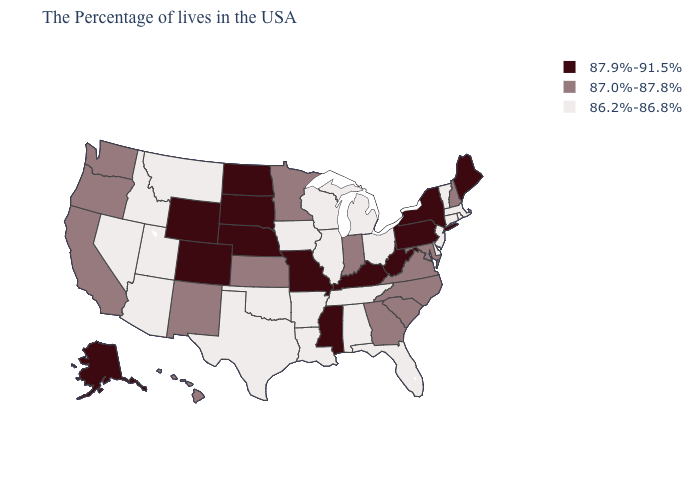What is the value of Indiana?
Write a very short answer. 87.0%-87.8%. How many symbols are there in the legend?
Answer briefly. 3. Name the states that have a value in the range 87.9%-91.5%?
Be succinct. Maine, New York, Pennsylvania, West Virginia, Kentucky, Mississippi, Missouri, Nebraska, South Dakota, North Dakota, Wyoming, Colorado, Alaska. Name the states that have a value in the range 86.2%-86.8%?
Concise answer only. Massachusetts, Rhode Island, Vermont, Connecticut, New Jersey, Delaware, Ohio, Florida, Michigan, Alabama, Tennessee, Wisconsin, Illinois, Louisiana, Arkansas, Iowa, Oklahoma, Texas, Utah, Montana, Arizona, Idaho, Nevada. Name the states that have a value in the range 86.2%-86.8%?
Quick response, please. Massachusetts, Rhode Island, Vermont, Connecticut, New Jersey, Delaware, Ohio, Florida, Michigan, Alabama, Tennessee, Wisconsin, Illinois, Louisiana, Arkansas, Iowa, Oklahoma, Texas, Utah, Montana, Arizona, Idaho, Nevada. What is the lowest value in the Northeast?
Keep it brief. 86.2%-86.8%. Is the legend a continuous bar?
Write a very short answer. No. What is the lowest value in the Northeast?
Write a very short answer. 86.2%-86.8%. Does Florida have a higher value than Washington?
Answer briefly. No. Does Kentucky have the highest value in the USA?
Concise answer only. Yes. Name the states that have a value in the range 86.2%-86.8%?
Quick response, please. Massachusetts, Rhode Island, Vermont, Connecticut, New Jersey, Delaware, Ohio, Florida, Michigan, Alabama, Tennessee, Wisconsin, Illinois, Louisiana, Arkansas, Iowa, Oklahoma, Texas, Utah, Montana, Arizona, Idaho, Nevada. Name the states that have a value in the range 87.9%-91.5%?
Keep it brief. Maine, New York, Pennsylvania, West Virginia, Kentucky, Mississippi, Missouri, Nebraska, South Dakota, North Dakota, Wyoming, Colorado, Alaska. What is the value of Vermont?
Write a very short answer. 86.2%-86.8%. What is the value of North Dakota?
Short answer required. 87.9%-91.5%. 